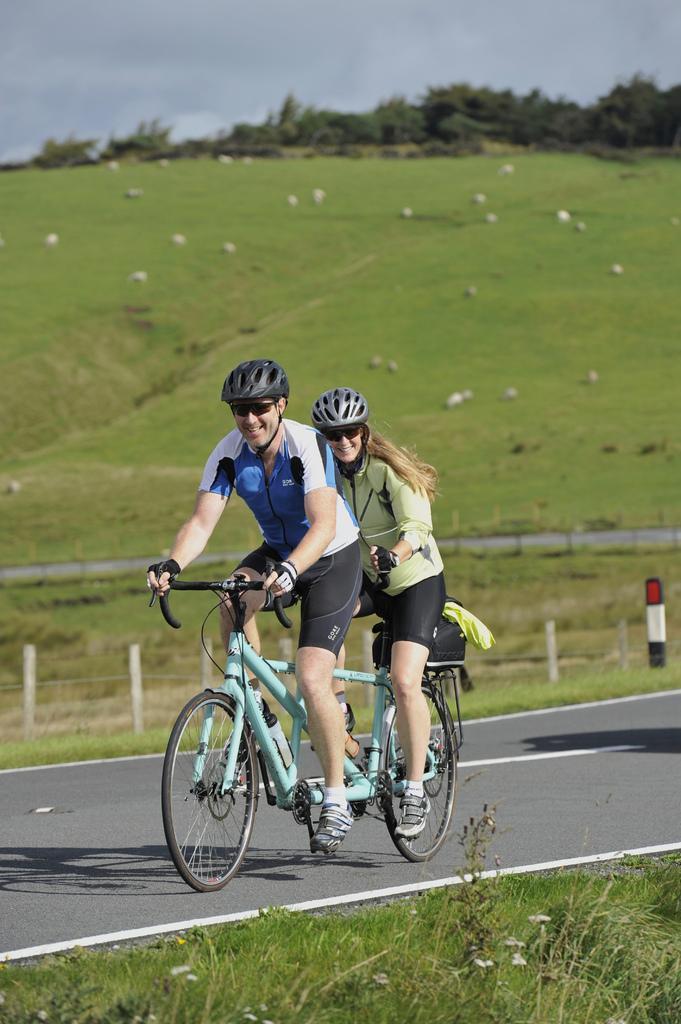In one or two sentences, can you explain what this image depicts? In this picture we can see man and woman wore helmet and smiling and riding bicycle on road beside to this we have grass, fence and in background we can see sky, trees. 